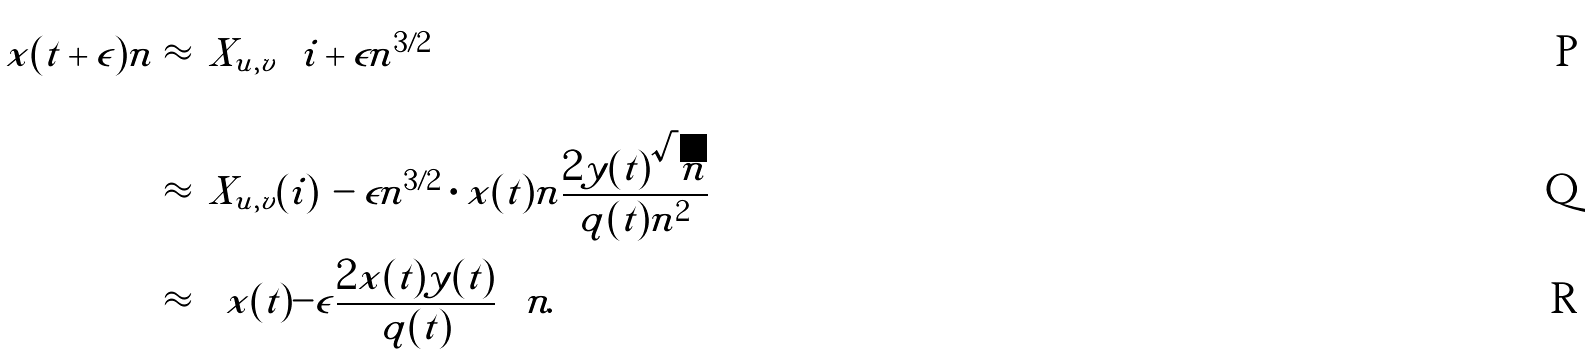<formula> <loc_0><loc_0><loc_500><loc_500>x ( t + \epsilon ) n & \approx \left | X _ { u , v } \left ( i + \epsilon n ^ { 3 / 2 } \right ) \right | \\ & \approx \left | X _ { u , v } ( i ) \right | - \epsilon n ^ { 3 / 2 } \cdot x ( t ) n \frac { 2 y ( t ) \sqrt { n } } { q ( t ) n ^ { 2 } } \\ & \approx \left ( x ( t ) - \epsilon \frac { 2 x ( t ) y ( t ) } { q ( t ) } \right ) n .</formula> 